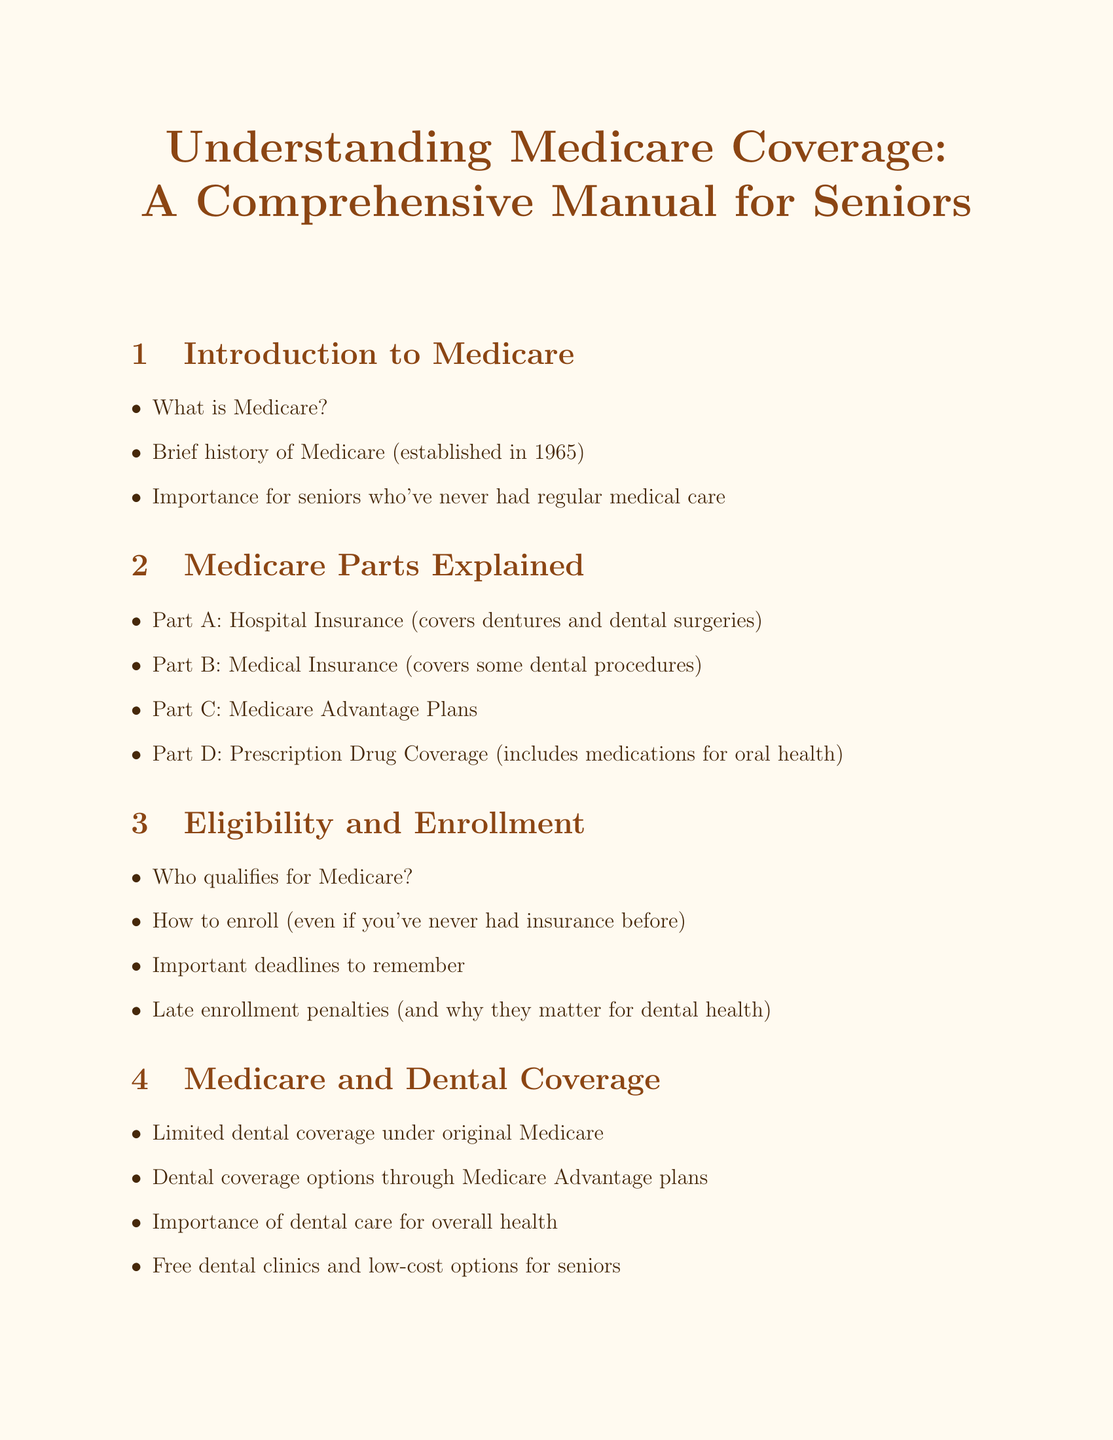What year was Medicare established? The document states that Medicare was established in 1965.
Answer: 1965 What does Part A cover? According to the document, Part A covers dentures and dental surgeries.
Answer: dentures and dental surgeries Who qualifies for Medicare? The document mentions who qualifies for Medicare but does not specify the criteria; this information reflects a common inquiry about eligibility status.
Answer: Who qualifies for Medicare? What is the significance of dental care mentioned in the document? The document emphasizes the importance of dental care for overall health.
Answer: overall health What is available under Medicare's preventive services? The document lists free preventive services under Medicare as an essential element of care.
Answer: free preventive services What is the Extra Help program? This program aids with prescription drugs, which may include dental medications.
Answer: prescription drugs What is a common resource for assistance mentioned in this manual? The document lists the State Health Insurance Assistance Program (SHIP) as a resource.
Answer: State Health Insurance Assistance Program (SHIP) How can seniors protect against Medicare fraud? The document advises on how to protect oneself from common Medicare scams targeting seniors.
Answer: protect yourself from fraud 